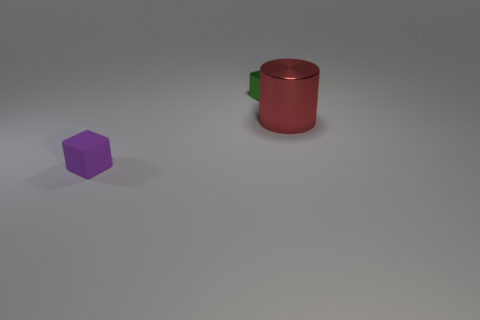Add 3 large red objects. How many objects exist? 6 Subtract all cylinders. How many objects are left? 2 Add 3 large objects. How many large objects exist? 4 Subtract 0 yellow cylinders. How many objects are left? 3 Subtract all blue cubes. Subtract all yellow spheres. How many cubes are left? 2 Subtract all big cyan cubes. Subtract all purple rubber things. How many objects are left? 2 Add 1 small metallic blocks. How many small metallic blocks are left? 2 